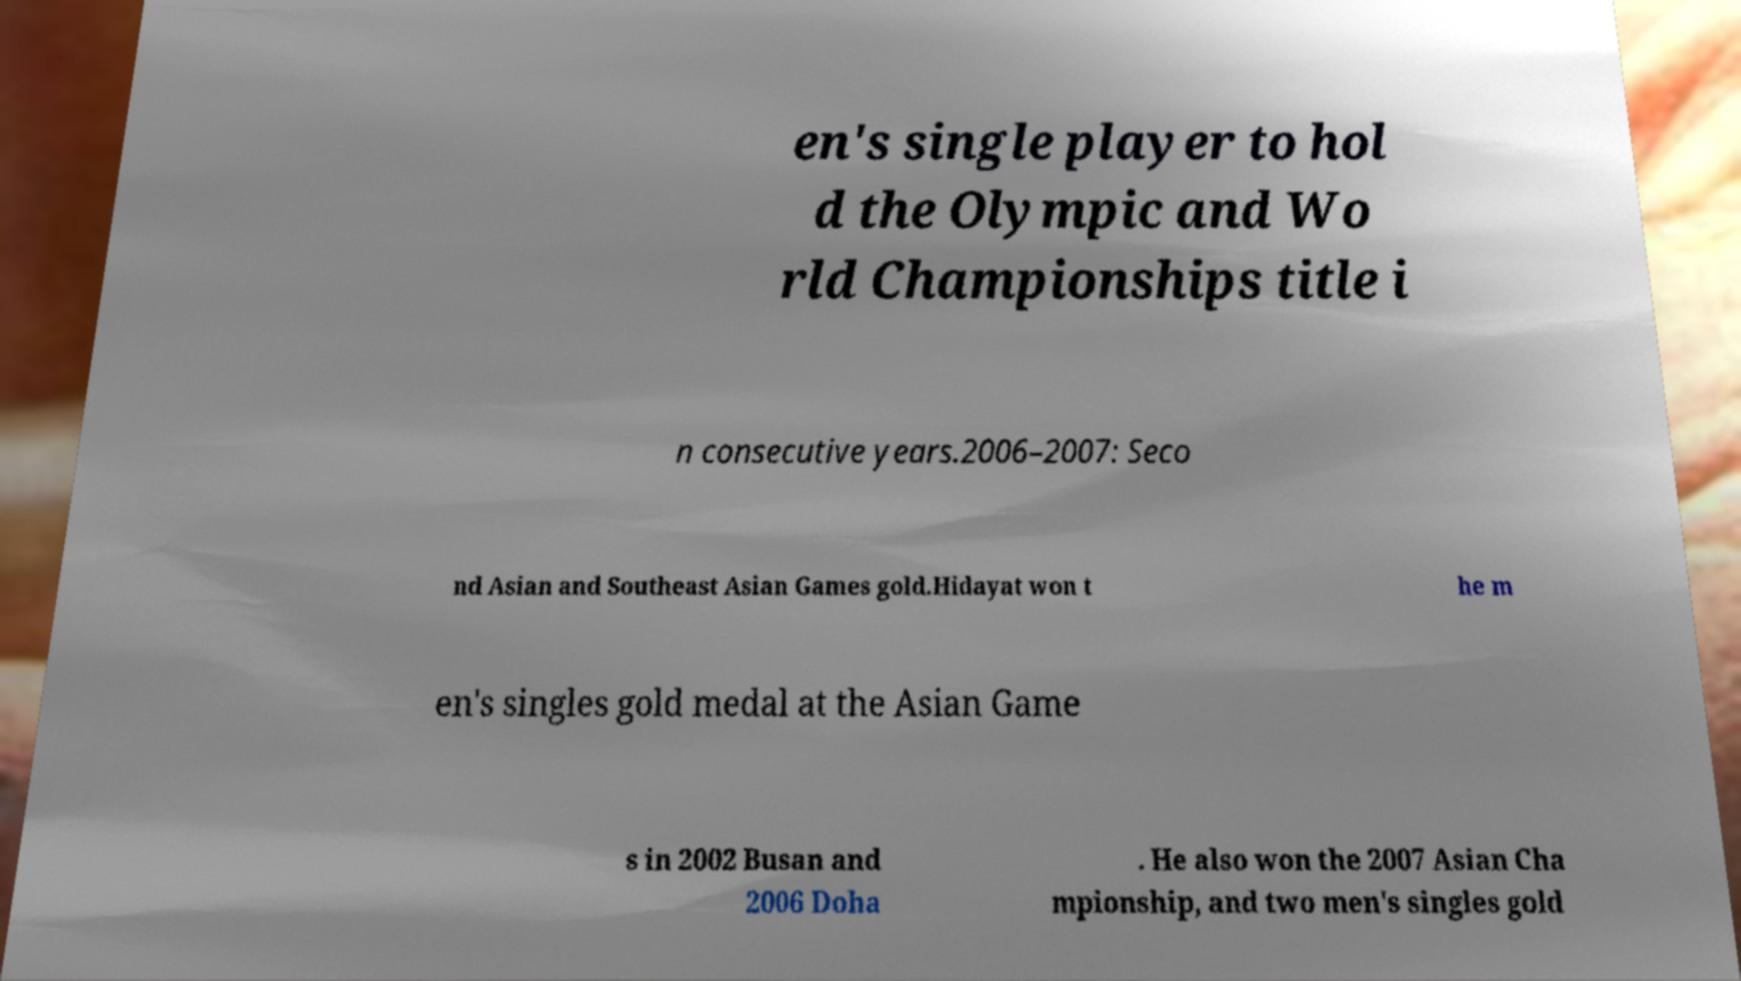Could you assist in decoding the text presented in this image and type it out clearly? en's single player to hol d the Olympic and Wo rld Championships title i n consecutive years.2006–2007: Seco nd Asian and Southeast Asian Games gold.Hidayat won t he m en's singles gold medal at the Asian Game s in 2002 Busan and 2006 Doha . He also won the 2007 Asian Cha mpionship, and two men's singles gold 